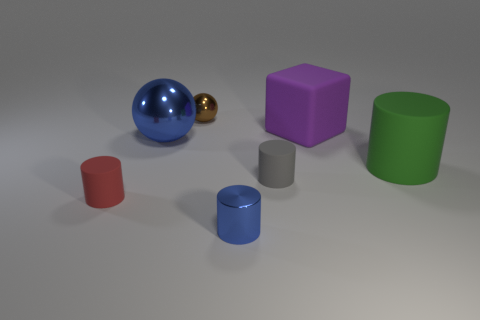What color is the metal ball that is in front of the tiny metal object left of the small blue cylinder? The metal ball positioned in front of the small object to the left of the blue cylinder is golden in color, exhibiting a shiny reflective surface that provides a striking contrast to the matte colors of the surrounding objects. 